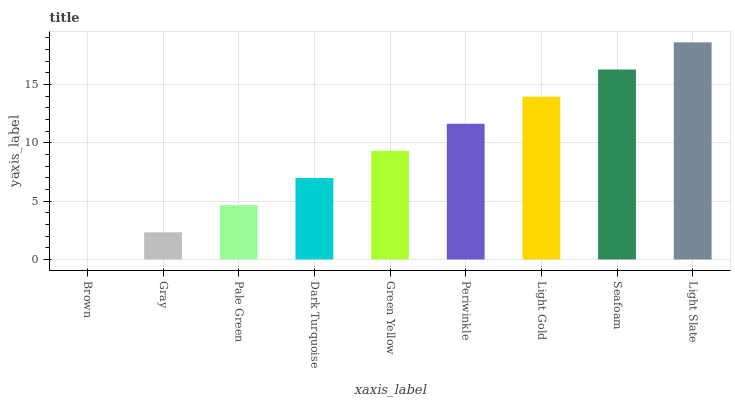Is Brown the minimum?
Answer yes or no. Yes. Is Light Slate the maximum?
Answer yes or no. Yes. Is Gray the minimum?
Answer yes or no. No. Is Gray the maximum?
Answer yes or no. No. Is Gray greater than Brown?
Answer yes or no. Yes. Is Brown less than Gray?
Answer yes or no. Yes. Is Brown greater than Gray?
Answer yes or no. No. Is Gray less than Brown?
Answer yes or no. No. Is Green Yellow the high median?
Answer yes or no. Yes. Is Green Yellow the low median?
Answer yes or no. Yes. Is Light Slate the high median?
Answer yes or no. No. Is Light Slate the low median?
Answer yes or no. No. 